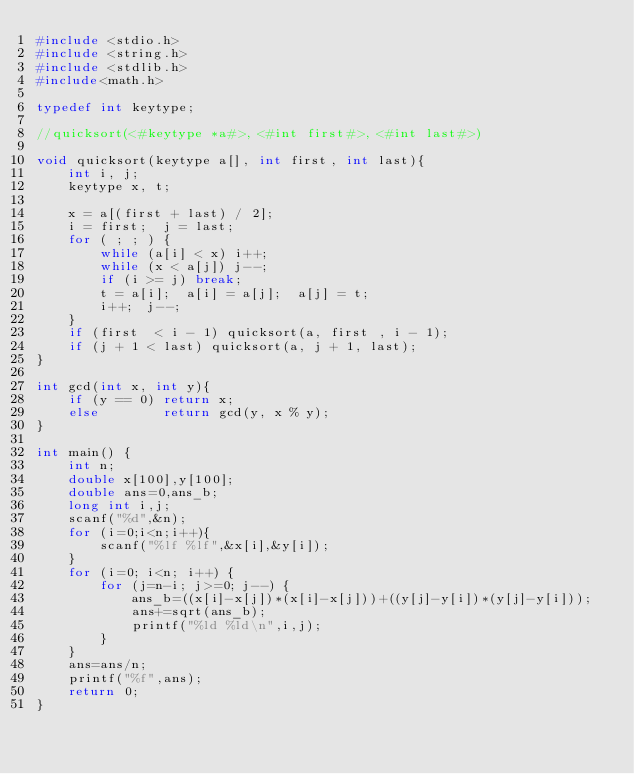Convert code to text. <code><loc_0><loc_0><loc_500><loc_500><_C_>#include <stdio.h>
#include <string.h>
#include <stdlib.h>
#include<math.h>

typedef int keytype;

//quicksort(<#keytype *a#>, <#int first#>, <#int last#>)

void quicksort(keytype a[], int first, int last){
    int i, j;
    keytype x, t;
    
    x = a[(first + last) / 2];
    i = first;  j = last;
    for ( ; ; ) {
        while (a[i] < x) i++;
        while (x < a[j]) j--;
        if (i >= j) break;
        t = a[i];  a[i] = a[j];  a[j] = t;
        i++;  j--;
    }
    if (first  < i - 1) quicksort(a, first , i - 1);
    if (j + 1 < last) quicksort(a, j + 1, last);
}

int gcd(int x, int y){
    if (y == 0) return x;
    else        return gcd(y, x % y);
}

int main() {
    int n;
    double x[100],y[100];
    double ans=0,ans_b;
    long int i,j;
    scanf("%d",&n);
    for (i=0;i<n;i++){
        scanf("%lf %lf",&x[i],&y[i]);
    }
    for (i=0; i<n; i++) {
        for (j=n-i; j>=0; j--) {
            ans_b=((x[i]-x[j])*(x[i]-x[j]))+((y[j]-y[i])*(y[j]-y[i]));
            ans+=sqrt(ans_b);
            printf("%ld %ld\n",i,j);
        }
    }
    ans=ans/n;
    printf("%f",ans);
    return 0;
}

</code> 